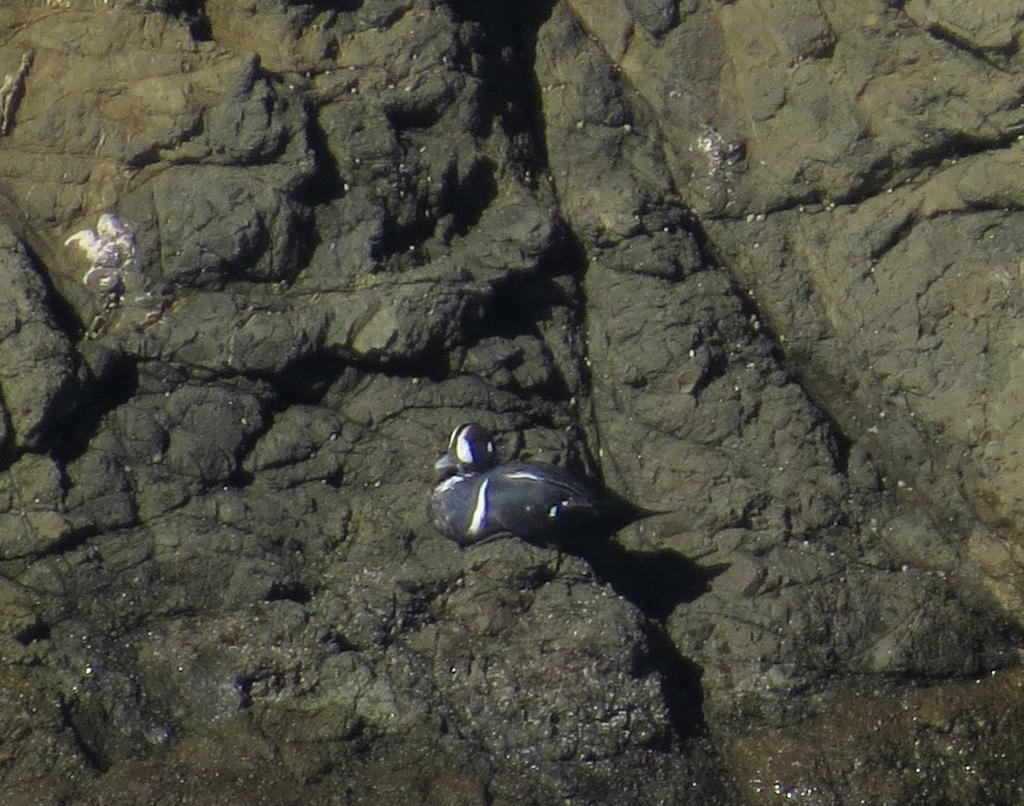What type of animal can be seen in the image? There is a bird in the image. Where is the bird located in the image? The bird is sitting on a rock. What type of dress is the bird wearing in the image? There is no dress present in the image, as the bird is a bird and not a person wearing clothing. 